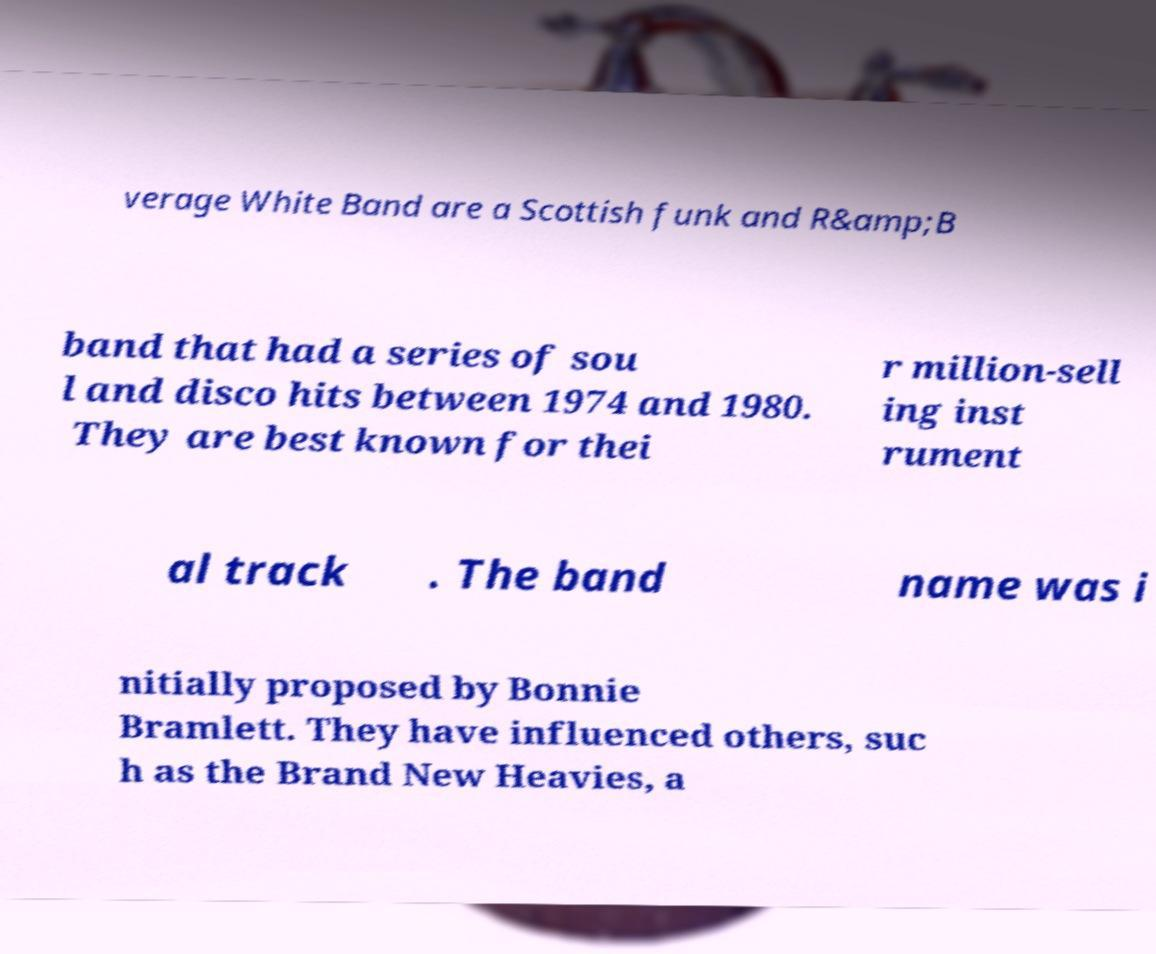Can you accurately transcribe the text from the provided image for me? verage White Band are a Scottish funk and R&amp;B band that had a series of sou l and disco hits between 1974 and 1980. They are best known for thei r million-sell ing inst rument al track . The band name was i nitially proposed by Bonnie Bramlett. They have influenced others, suc h as the Brand New Heavies, a 